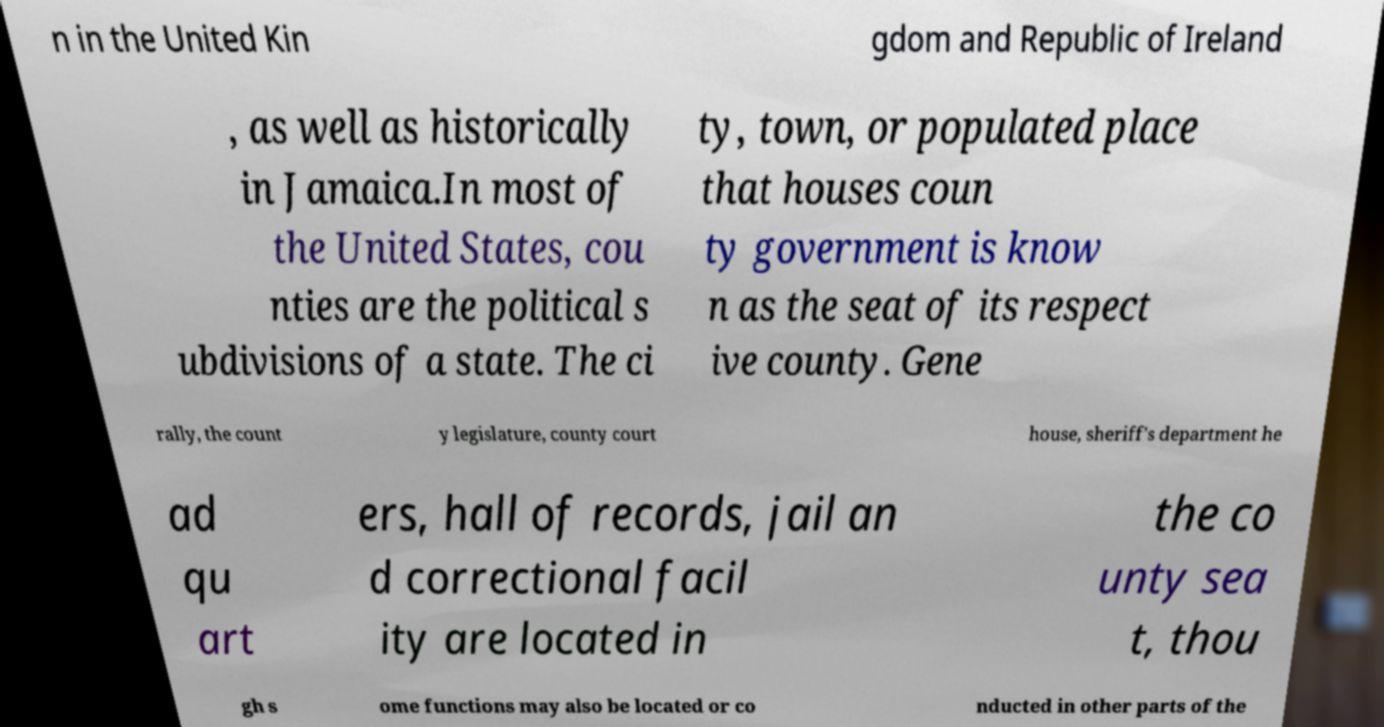There's text embedded in this image that I need extracted. Can you transcribe it verbatim? n in the United Kin gdom and Republic of Ireland , as well as historically in Jamaica.In most of the United States, cou nties are the political s ubdivisions of a state. The ci ty, town, or populated place that houses coun ty government is know n as the seat of its respect ive county. Gene rally, the count y legislature, county court house, sheriff's department he ad qu art ers, hall of records, jail an d correctional facil ity are located in the co unty sea t, thou gh s ome functions may also be located or co nducted in other parts of the 